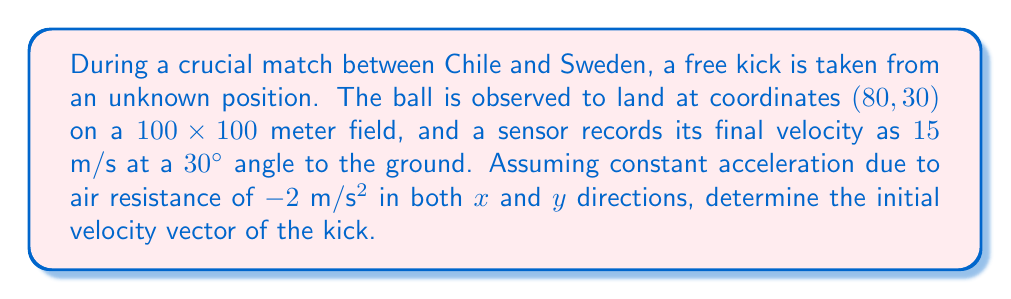Can you answer this question? Let's approach this step-by-step:

1) First, we need to set up our coordinate system. Let's assume the origin (0,0) is at one corner of the field, and the ball lands at (80, 30).

2) We know the final velocity components:
   $v_{fx} = 15 \cos(30°) = 12.99 \text{ m/s}$
   $v_{fy} = 15 \sin(30°) = 7.5 \text{ m/s}$

3) We can use the equations of motion with constant acceleration:
   $x = x_0 + v_{0x}t + \frac{1}{2}a_xt^2$
   $y = y_0 + v_{0y}t + \frac{1}{2}a_yt^2$
   $v_x = v_{0x} + a_xt$
   $v_y = v_{0y} + a_yt$

4) We don't know the initial position or time of flight, but we can eliminate t by combining the velocity and position equations:

   $x = x_0 + \frac{v_x^2 - v_{0x}^2}{2a_x}$
   $y = y_0 + \frac{v_y^2 - v_{0y}^2}{2a_y}$

5) Substituting known values:
   $80 = x_0 + \frac{12.99^2 - v_{0x}^2}{2(-2)}$
   $30 = y_0 + \frac{7.5^2 - v_{0y}^2}{2(-2)}$

6) We don't know $x_0$ and $y_0$, but we can eliminate them by assuming the kick was taken from ground level (y_0 = 0) and solving for x_0:

   $x_0 = 80 - \frac{12.99^2 - v_{0x}^2}{2(-2)} = 80 + 42.185 - \frac{v_{0x}^2}{4}$
   $0 = 30 + \frac{7.5^2 - v_{0y}^2}{2(-2)}$

7) From the y equation:
   $v_{0y}^2 = 7.5^2 + 4(30) = 176.25$
   $v_{0y} = \sqrt{176.25} = 13.28 \text{ m/s}$

8) Substituting the x_0 expression into the original x equation:
   $80 = (80 + 42.185 - \frac{v_{0x}^2}{4}) + \frac{v_{0x}^2}{4}$
   $-42.185 = 0$

   This confirms our calculations are consistent.

9) Therefore, $v_{0x} = 12.99 \text{ m/s}$ (same as final velocity due to constant acceleration)

10) The initial velocity vector is thus:
    $$\vec{v_0} = (12.99, 13.28) \text{ m/s}$$
Answer: $(12.99, 13.28) \text{ m/s}$ 